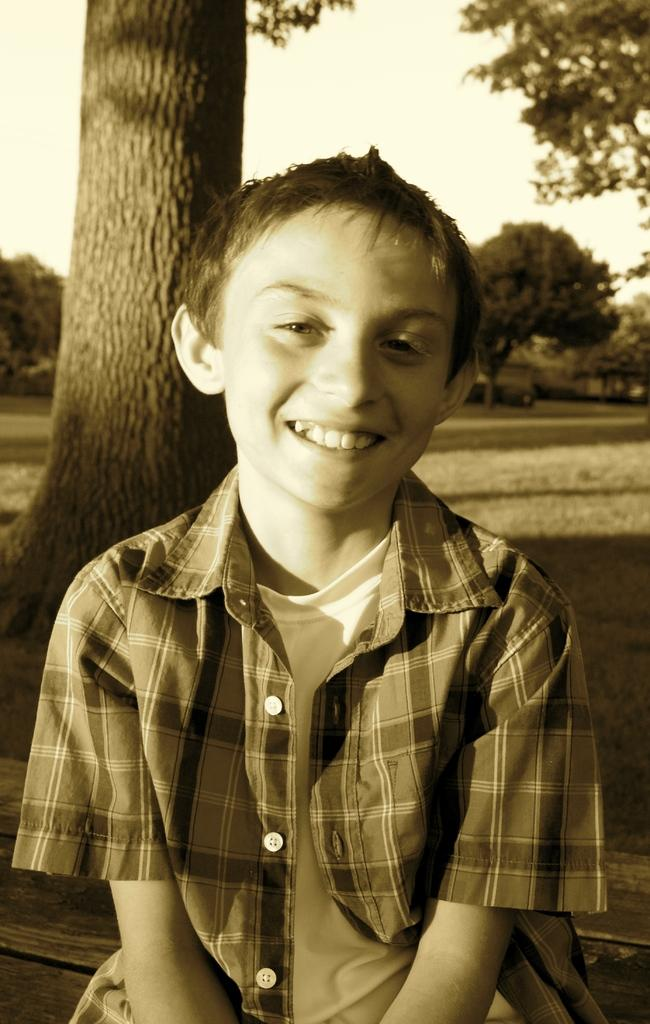Who is in the picture? There is a boy in the picture. What is the boy doing in the picture? The boy is sitting. What is the boy wearing in the picture? The boy is wearing a shirt on a T-shirt. What is the boy's facial expression in the picture? The boy is smiling. What can be seen behind the boy in the picture? There is a tree behind the boy. What else can be seen in the distance in the picture? There are many trees visible in the distance. What part of the natural environment is visible in the picture? The sky is visible in the image. What type of juice is the boy holding in the picture? There is no juice present in the image; the boy is not holding any drink. 